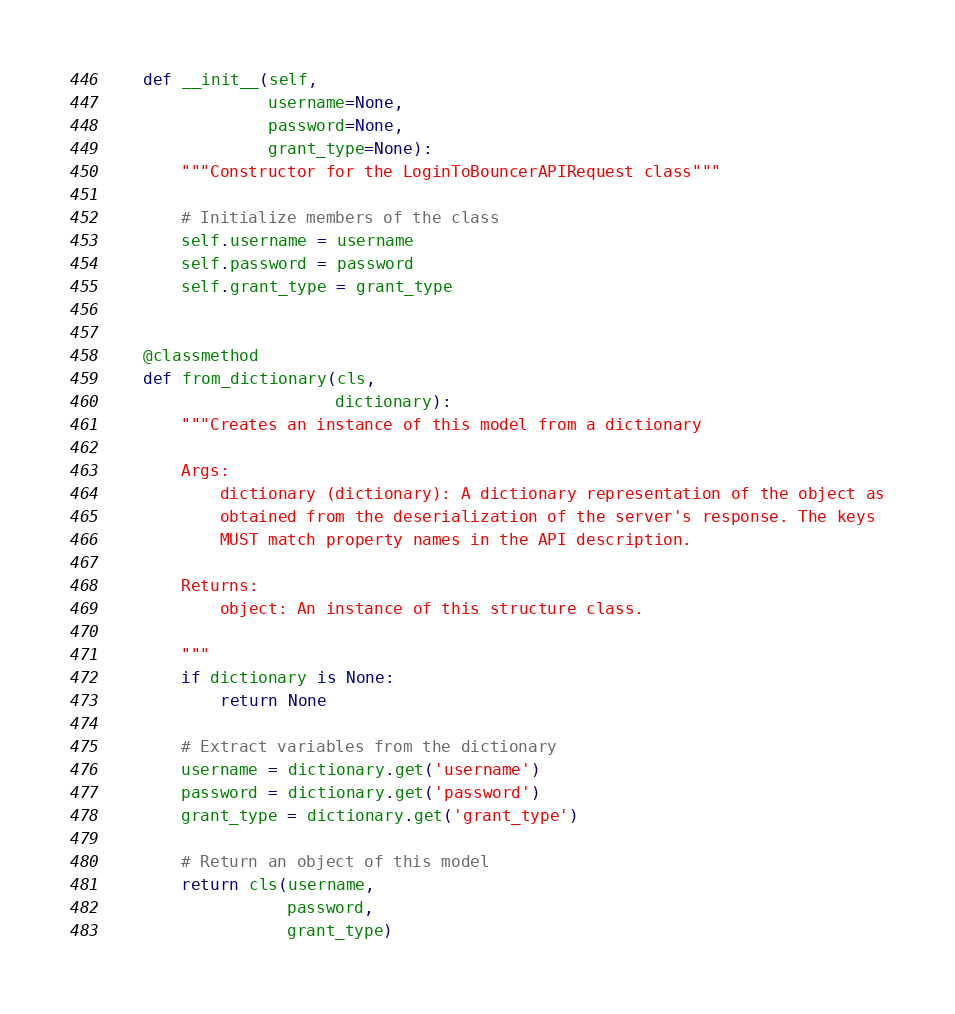Convert code to text. <code><loc_0><loc_0><loc_500><loc_500><_Python_>
    def __init__(self,
                 username=None,
                 password=None,
                 grant_type=None):
        """Constructor for the LoginToBouncerAPIRequest class"""

        # Initialize members of the class
        self.username = username
        self.password = password
        self.grant_type = grant_type


    @classmethod
    def from_dictionary(cls,
                        dictionary):
        """Creates an instance of this model from a dictionary

        Args:
            dictionary (dictionary): A dictionary representation of the object as
            obtained from the deserialization of the server's response. The keys
            MUST match property names in the API description.

        Returns:
            object: An instance of this structure class.

        """
        if dictionary is None:
            return None

        # Extract variables from the dictionary
        username = dictionary.get('username')
        password = dictionary.get('password')
        grant_type = dictionary.get('grant_type')

        # Return an object of this model
        return cls(username,
                   password,
                   grant_type)


</code> 